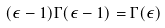Convert formula to latex. <formula><loc_0><loc_0><loc_500><loc_500>( \epsilon - 1 ) \Gamma ( \epsilon - 1 ) = \Gamma ( \epsilon )</formula> 